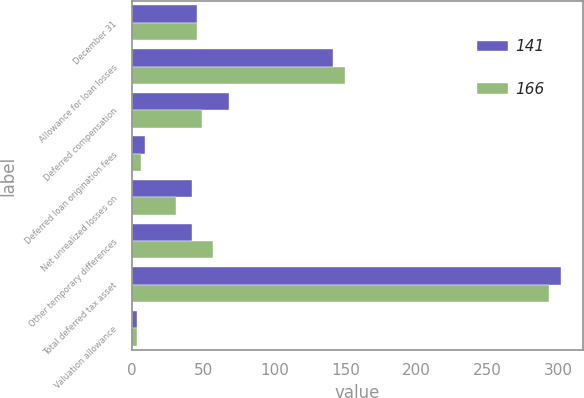Convert chart to OTSL. <chart><loc_0><loc_0><loc_500><loc_500><stacked_bar_chart><ecel><fcel>December 31<fcel>Allowance for loan losses<fcel>Deferred compensation<fcel>Deferred loan origination fees<fcel>Net unrealized losses on<fcel>Other temporary differences<fcel>Total deferred tax asset<fcel>Valuation allowance<nl><fcel>141<fcel>45.5<fcel>141<fcel>68<fcel>9<fcel>42<fcel>42<fcel>302<fcel>3<nl><fcel>166<fcel>45.5<fcel>150<fcel>49<fcel>6<fcel>31<fcel>57<fcel>293<fcel>3<nl></chart> 